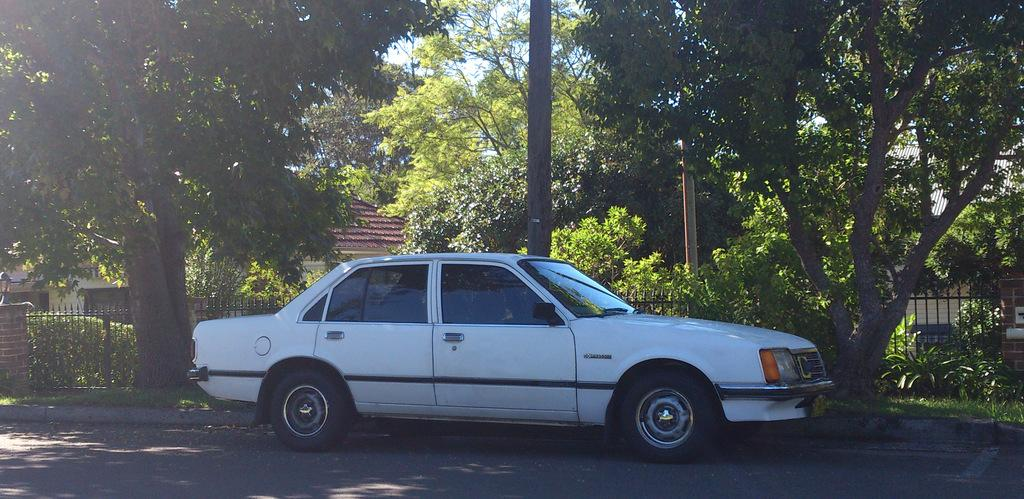What type of vehicle is in the image? There is a white car in the image. Where is the car located? The car is parked on the road side. What else can be seen in the image besides the car? There is a black railing grill and trees visible in the image. Can you see a farmer holding a gun in the image? There is no farmer or gun present in the image. What type of coil is wrapped around the trees in the image? There is no coil visible in the image; only trees are present. 